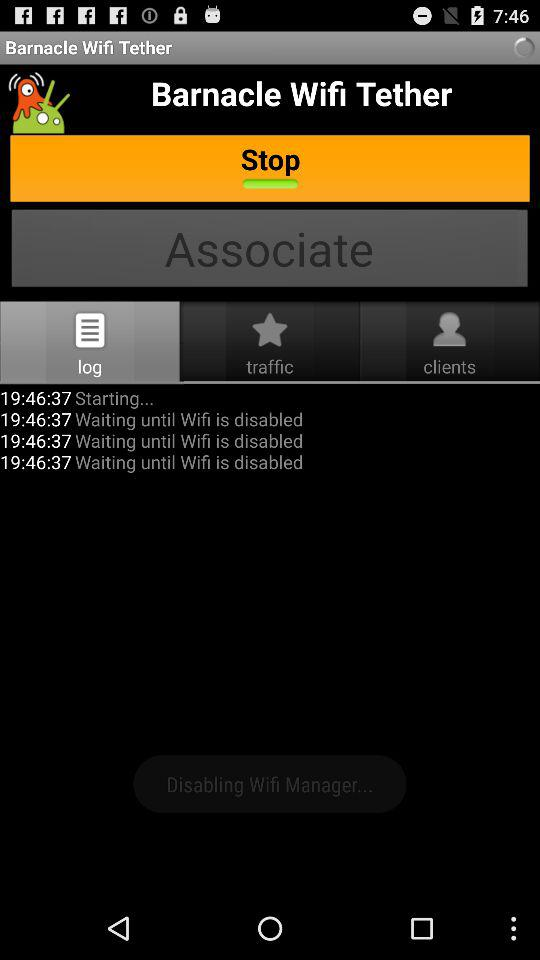What is the start time of WiFi in the log? The start time of WiFi in the log is 19:46:37. 